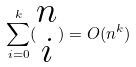<formula> <loc_0><loc_0><loc_500><loc_500>\sum _ { i = 0 } ^ { k } ( \begin{matrix} n \\ i \end{matrix} ) = O ( n ^ { k } )</formula> 